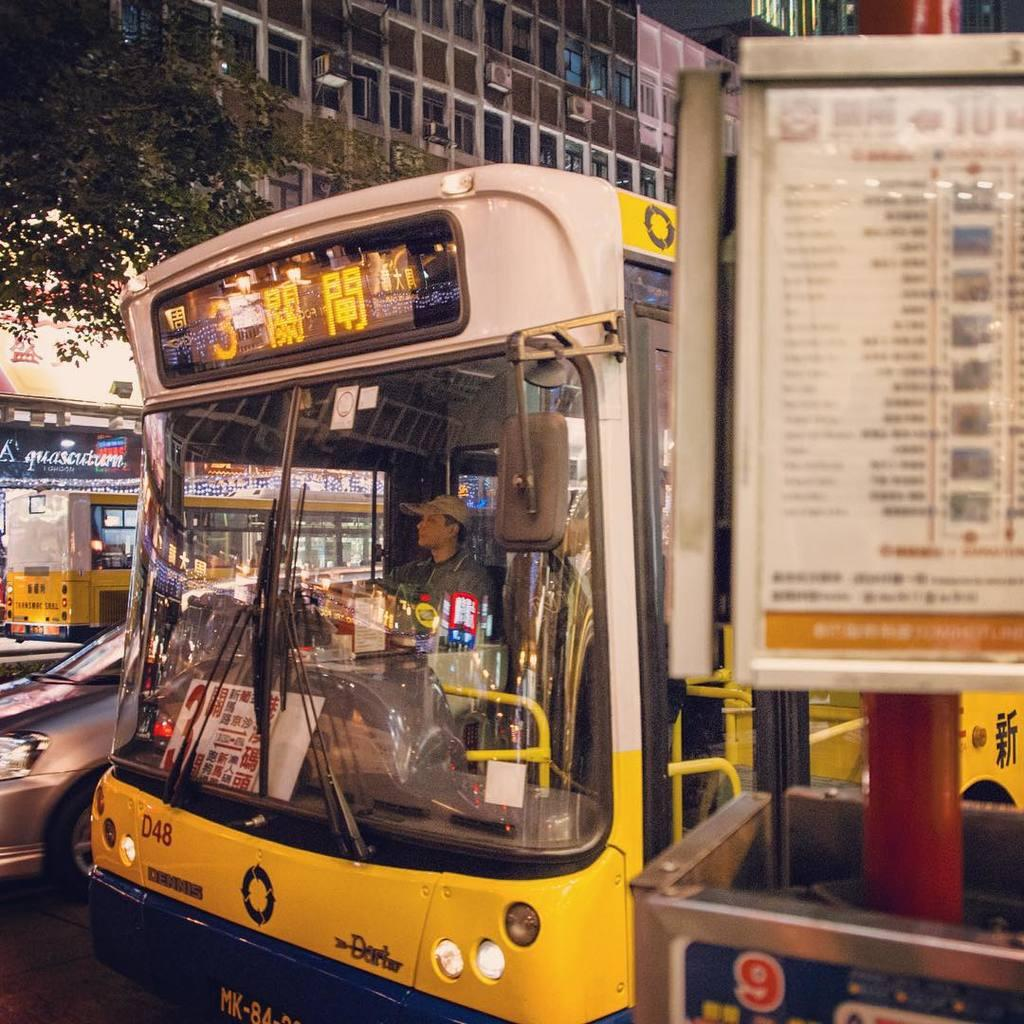Provide a one-sentence caption for the provided image. The number 3 bus is yellow and stopped at the bus stop. 